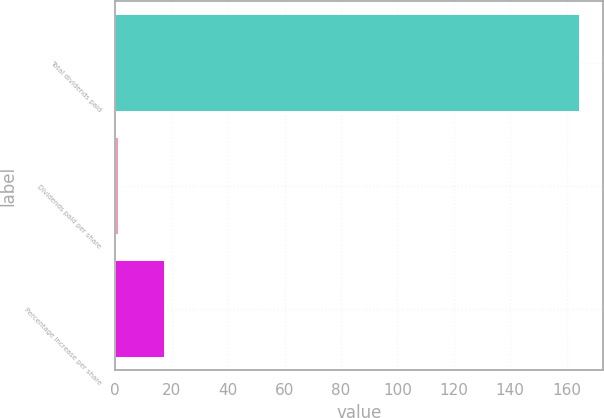<chart> <loc_0><loc_0><loc_500><loc_500><bar_chart><fcel>Total dividends paid<fcel>Dividends paid per share<fcel>Percentage increase per share<nl><fcel>164.7<fcel>1.24<fcel>17.59<nl></chart> 